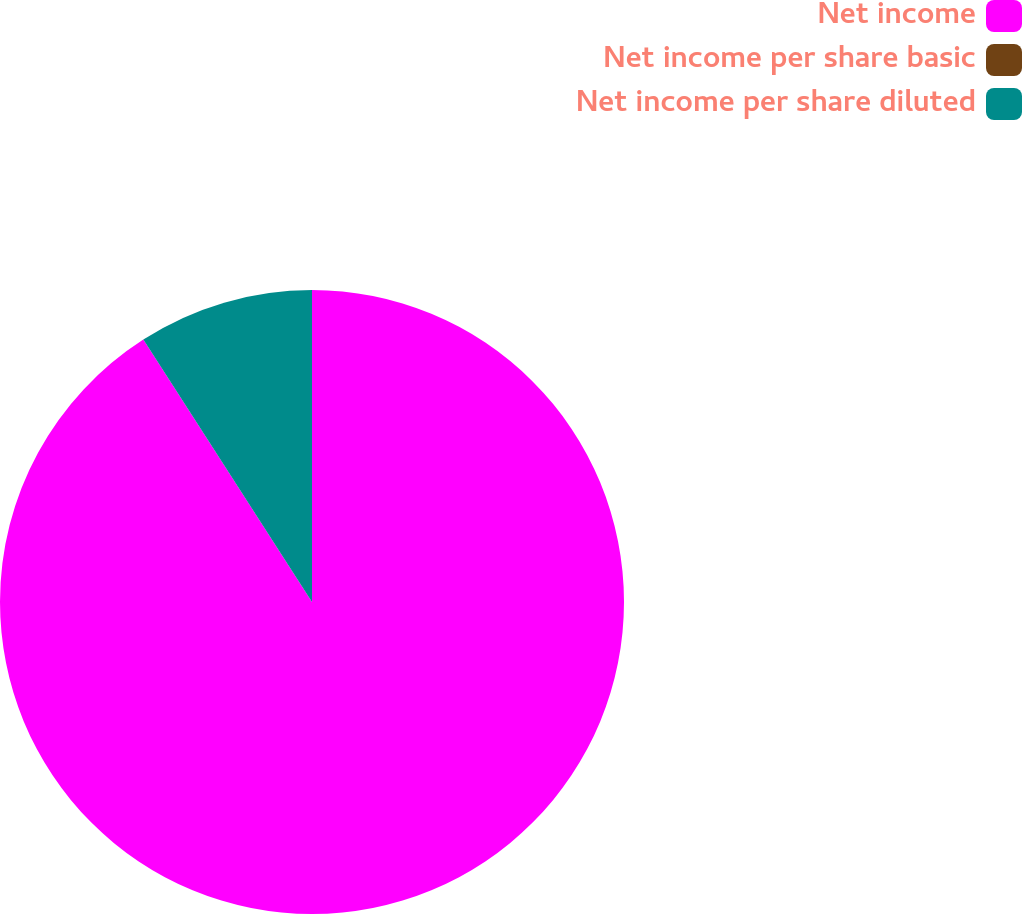Convert chart. <chart><loc_0><loc_0><loc_500><loc_500><pie_chart><fcel>Net income<fcel>Net income per share basic<fcel>Net income per share diluted<nl><fcel>90.91%<fcel>0.0%<fcel>9.09%<nl></chart> 